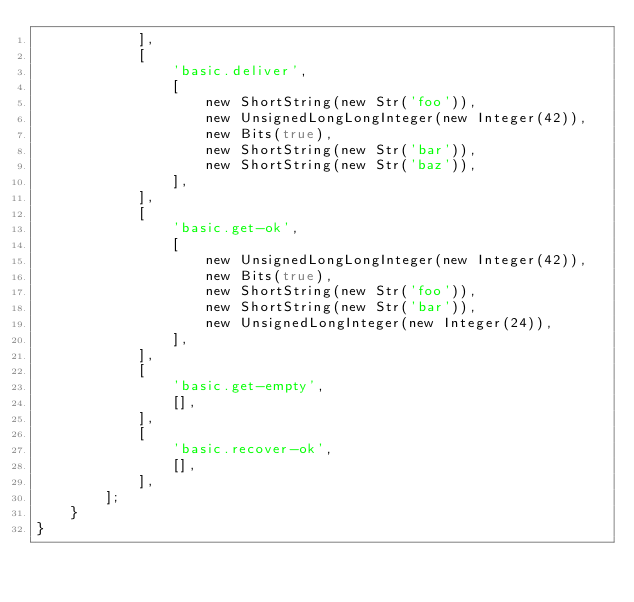Convert code to text. <code><loc_0><loc_0><loc_500><loc_500><_PHP_>            ],
            [
                'basic.deliver',
                [
                    new ShortString(new Str('foo')),
                    new UnsignedLongLongInteger(new Integer(42)),
                    new Bits(true),
                    new ShortString(new Str('bar')),
                    new ShortString(new Str('baz')),
                ],
            ],
            [
                'basic.get-ok',
                [
                    new UnsignedLongLongInteger(new Integer(42)),
                    new Bits(true),
                    new ShortString(new Str('foo')),
                    new ShortString(new Str('bar')),
                    new UnsignedLongInteger(new Integer(24)),
                ],
            ],
            [
                'basic.get-empty',
                [],
            ],
            [
                'basic.recover-ok',
                [],
            ],
        ];
    }
}
</code> 